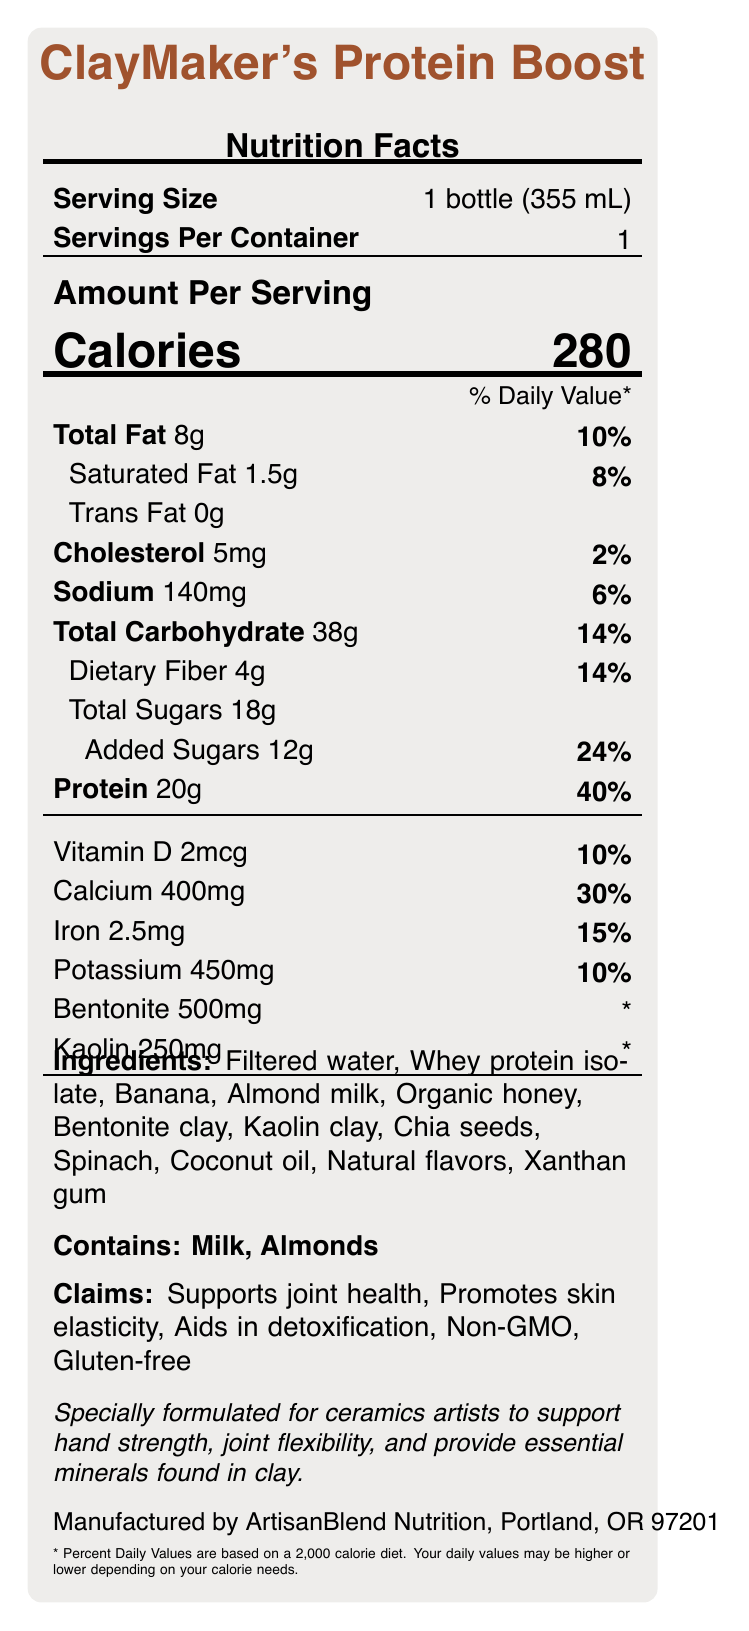what is the serving size? The serving size is stated explicitly on the Nutrition Facts label as "1 bottle (355 mL)".
Answer: 1 bottle (355 mL) how many calories are in one serving? The calories per serving are stated as "Calories 280".
Answer: 280 What is the total fat content per serving? The total fat per serving is listed as "Total Fat 8g" on the Nutrition Facts label.
Answer: 8g which ingredient provides the most protein? Among the listed ingredients, whey protein isolate is known for its high protein content.
Answer: Whey protein isolate how much calcium is present per serving? The calcium content is listed as "Calcium 400mg" on the Nutrition Facts label.
Answer: 400mg how many grams of dietary fiber does the smoothie contain? The dietary fiber content per serving is stated as "Dietary Fiber 4g".
Answer: 4g What is the main claim for ceramics artists? The main claim for ceramics artists is described as "Specially formulated for ceramics artists to support hand strength, joint flexibility, and provide essential minerals found in clay."
Answer: Supports hand strength, joint flexibility, and provides essential minerals found in clay. How many servings per container? The number of servings per container is listed as "Servings Per Container 1".
Answer: 1 What is the sodium content per serving? The sodium content per serving is listed as "Sodium 140mg" on the Nutrition Facts label.
Answer: 140mg What percentage of daily value is the added sugars? The daily value percentage for added sugars is listed as "Added Sugars 12g 24%".
Answer: 24% which of the following is NOT an ingredient in the smoothie? A. Filtered water B. Bentonite clay C. Flax seeds D. Honey Flax seeds are not listed among the ingredients; filtered water, bentonite clay, and honey are all included.
Answer: C. Flax seeds this product has been certified gluten-free. True or False? It is explicitly stated under the claims and certifications section that the product is "Gluten-free".
Answer: True What percentage of daily value does the protein content cover? The protein content per serving covers 40% of the daily value.
Answer: 40% Summarize the primary purpose of "ClayMaker's Protein Boost". This summary is based on the unique formulation and claims made in the document, particularly focusing on how the product is beneficial for ceramics artists.
Answer: The primary purpose of "ClayMaker's Protein Boost" is to provide a nutritious, high-protein smoothie specially formulated for ceramics artists to support their hand strength, joint flexibility, and provide essential minerals commonly found in clay, while also supporting overall health with various claims such as joint health and skin elasticity. What is the exact amount of "Natural flavors" used in the smoothie? The Nutrition Facts label lists "Natural flavors" as an ingredient, but it does not specify the exact amount used.
Answer: Cannot be determined what does the product claim regarding joint health? The claim regarding joint health is explicitly stated as "Supports joint health" in the claims section.
Answer: Supports joint health 